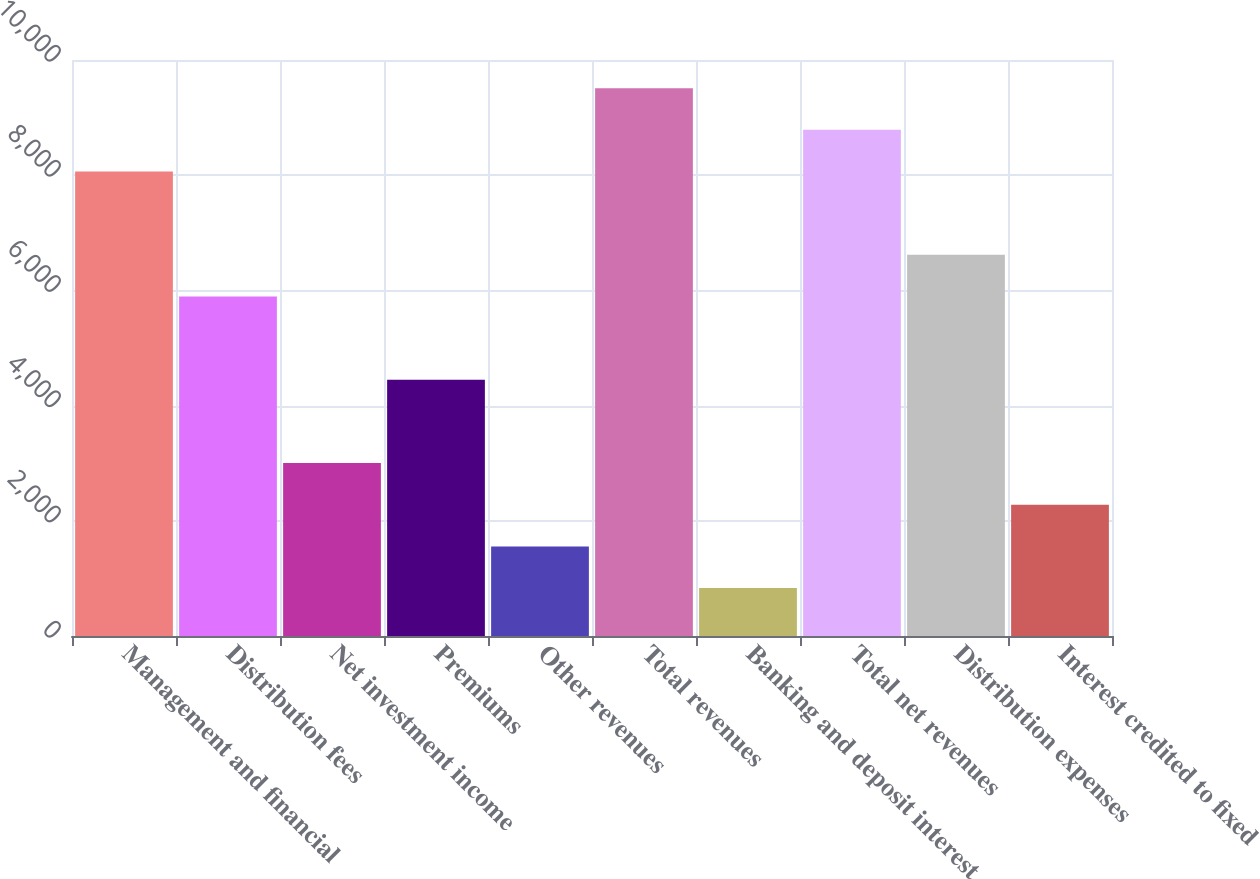<chart> <loc_0><loc_0><loc_500><loc_500><bar_chart><fcel>Management and financial<fcel>Distribution fees<fcel>Net investment income<fcel>Premiums<fcel>Other revenues<fcel>Total revenues<fcel>Banking and deposit interest<fcel>Total net revenues<fcel>Distribution expenses<fcel>Interest credited to fixed<nl><fcel>8064.2<fcel>5894.6<fcel>3001.8<fcel>4448.2<fcel>1555.4<fcel>9510.6<fcel>832.2<fcel>8787.4<fcel>6617.8<fcel>2278.6<nl></chart> 